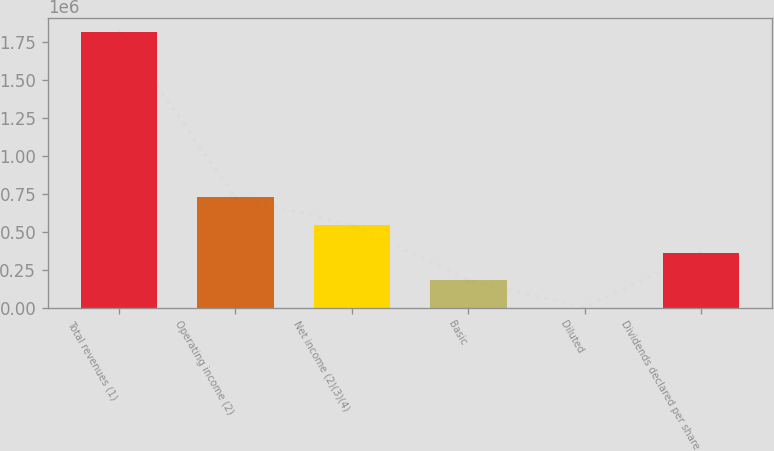Convert chart. <chart><loc_0><loc_0><loc_500><loc_500><bar_chart><fcel>Total revenues (1)<fcel>Operating income (2)<fcel>Net income (2)(3)(4)<fcel>Basic<fcel>Diluted<fcel>Dividends declared per share<nl><fcel>1.8156e+06<fcel>726240<fcel>544680<fcel>181560<fcel>0.2<fcel>363120<nl></chart> 